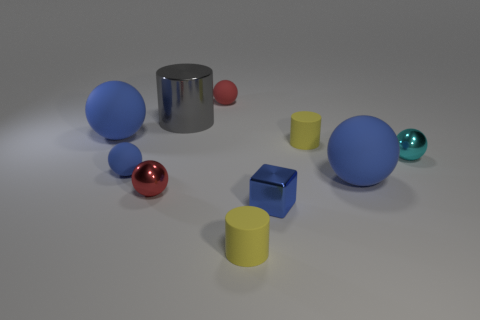Subtract all red spheres. How many spheres are left? 4 Subtract all red cylinders. How many blue balls are left? 3 Subtract all cyan balls. How many balls are left? 5 Subtract 1 cylinders. How many cylinders are left? 2 Subtract all red cylinders. Subtract all gray balls. How many cylinders are left? 3 Subtract all blue objects. Subtract all green matte spheres. How many objects are left? 6 Add 7 large gray metallic objects. How many large gray metallic objects are left? 8 Add 6 blue matte balls. How many blue matte balls exist? 9 Subtract 1 blue blocks. How many objects are left? 9 Subtract all cylinders. How many objects are left? 7 